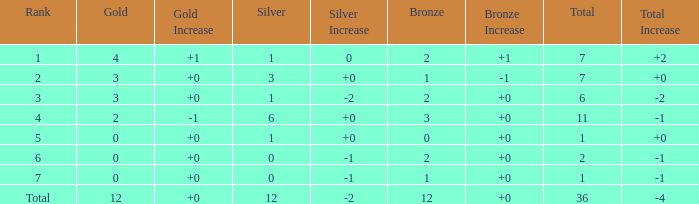What is the number of bronze medals when there are fewer than 0 silver medals? None. 